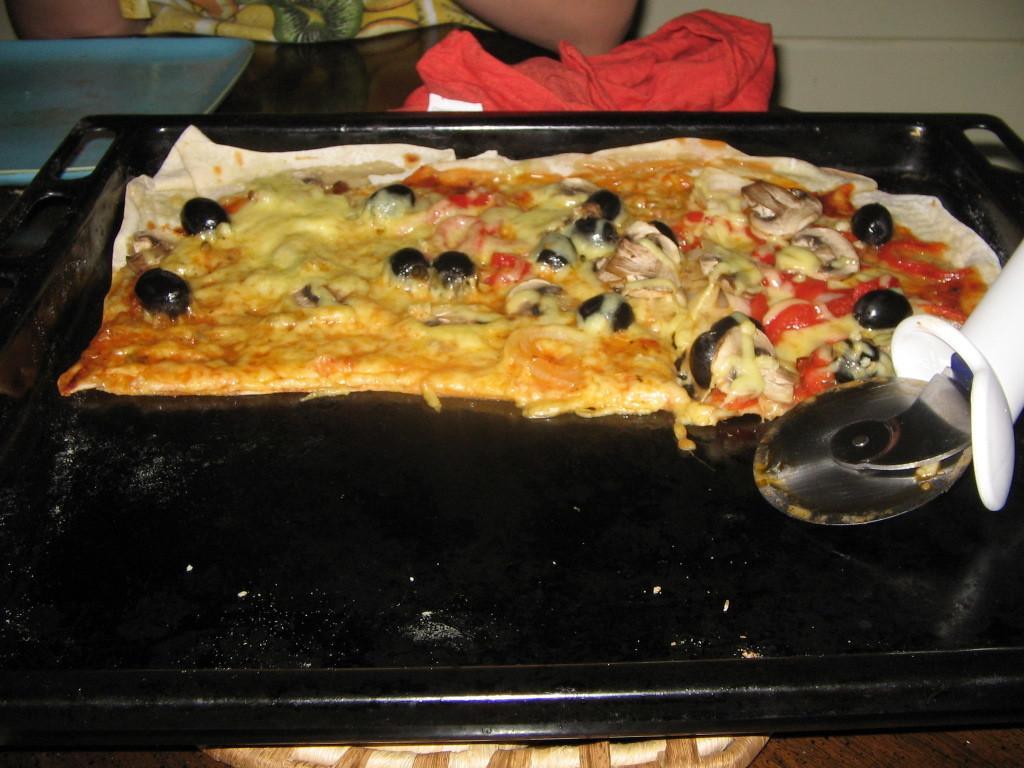Describe this image in one or two sentences. In this picture I can see there is some food placed in a tray, there is a cutter and there is a person sitting in the backdrop. There is a red color object placed on the table. 